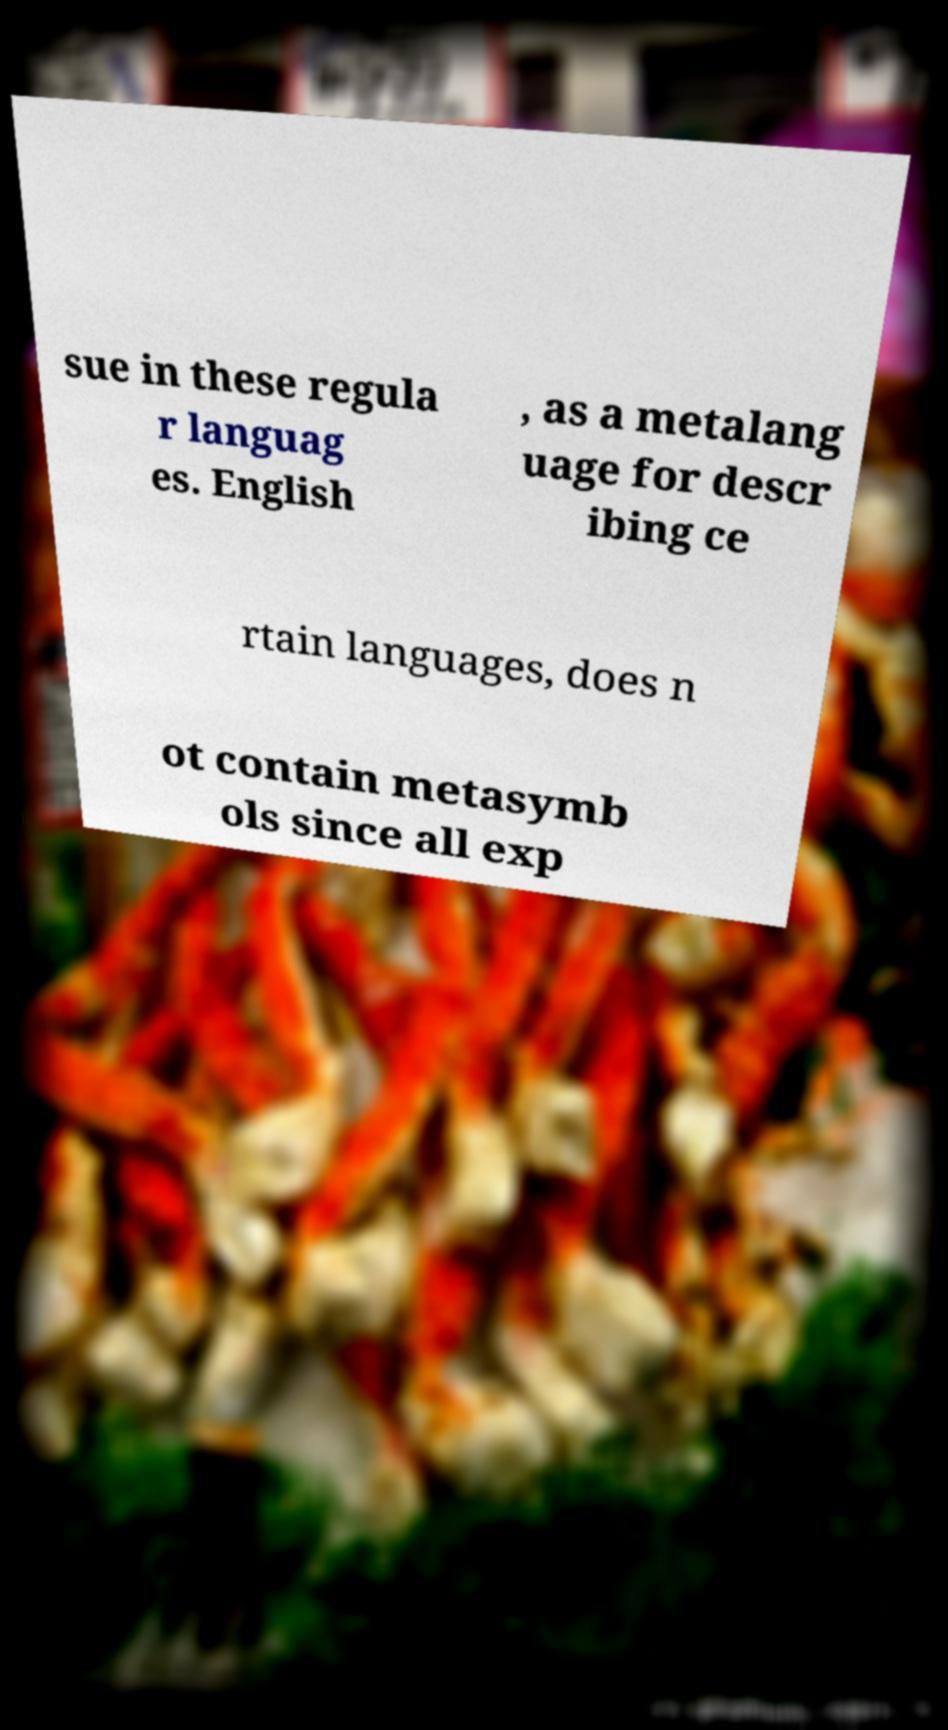Could you assist in decoding the text presented in this image and type it out clearly? sue in these regula r languag es. English , as a metalang uage for descr ibing ce rtain languages, does n ot contain metasymb ols since all exp 